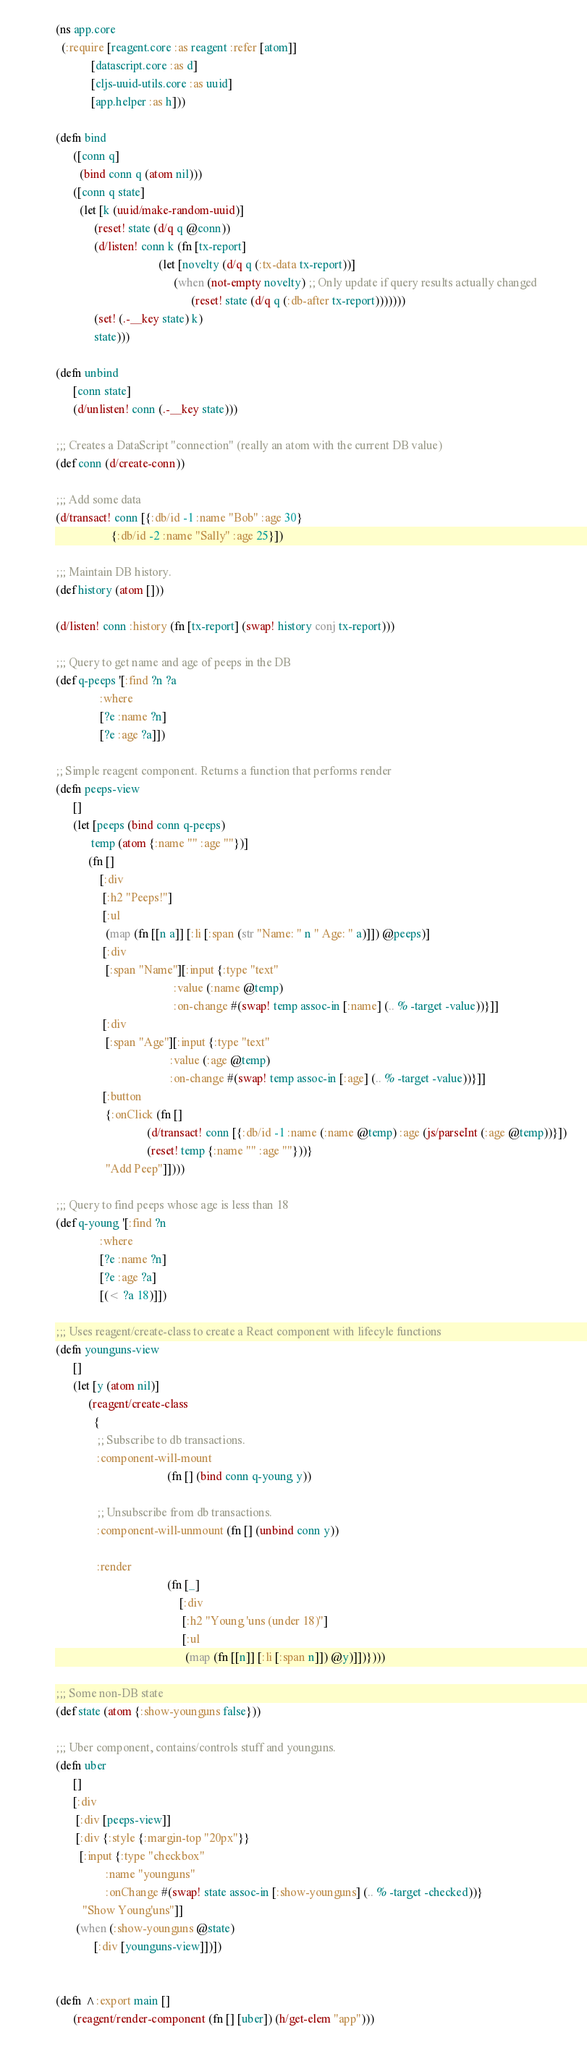<code> <loc_0><loc_0><loc_500><loc_500><_Clojure_>(ns app.core
  (:require [reagent.core :as reagent :refer [atom]]
            [datascript.core :as d]
            [cljs-uuid-utils.core :as uuid]
            [app.helper :as h]))

(defn bind
      ([conn q]
        (bind conn q (atom nil)))
      ([conn q state]
        (let [k (uuid/make-random-uuid)]
             (reset! state (d/q q @conn))
             (d/listen! conn k (fn [tx-report]
                                   (let [novelty (d/q q (:tx-data tx-report))]
                                        (when (not-empty novelty) ;; Only update if query results actually changed
                                              (reset! state (d/q q (:db-after tx-report)))))))
             (set! (.-__key state) k)
             state)))

(defn unbind
      [conn state]
      (d/unlisten! conn (.-__key state)))

;;; Creates a DataScript "connection" (really an atom with the current DB value)
(def conn (d/create-conn))

;;; Add some data
(d/transact! conn [{:db/id -1 :name "Bob" :age 30}
                   {:db/id -2 :name "Sally" :age 25}])

;;; Maintain DB history.
(def history (atom []))

(d/listen! conn :history (fn [tx-report] (swap! history conj tx-report)))

;;; Query to get name and age of peeps in the DB
(def q-peeps '[:find ?n ?a
               :where
               [?e :name ?n]
               [?e :age ?a]])

;; Simple reagent component. Returns a function that performs render
(defn peeps-view
      []
      (let [peeps (bind conn q-peeps)
            temp (atom {:name "" :age ""})]
           (fn []
               [:div
                [:h2 "Peeps!"]
                [:ul
                 (map (fn [[n a]] [:li [:span (str "Name: " n " Age: " a)]]) @peeps)]
                [:div
                 [:span "Name"][:input {:type "text"
                                        :value (:name @temp)
                                        :on-change #(swap! temp assoc-in [:name] (.. % -target -value))}]]
                [:div
                 [:span "Age"][:input {:type "text"
                                       :value (:age @temp)
                                       :on-change #(swap! temp assoc-in [:age] (.. % -target -value))}]]
                [:button
                 {:onClick (fn []
                               (d/transact! conn [{:db/id -1 :name (:name @temp) :age (js/parseInt (:age @temp))}])
                               (reset! temp {:name "" :age ""}))}
                 "Add Peep"]])))

;;; Query to find peeps whose age is less than 18
(def q-young '[:find ?n
               :where
               [?e :name ?n]
               [?e :age ?a]
               [(< ?a 18)]])

;;; Uses reagent/create-class to create a React component with lifecyle functions
(defn younguns-view
      []
      (let [y (atom nil)]
           (reagent/create-class
             {
              ;; Subscribe to db transactions.
              :component-will-mount
                                      (fn [] (bind conn q-young y))

              ;; Unsubscribe from db transactions.
              :component-will-unmount (fn [] (unbind conn y))

              :render
                                      (fn [_]
                                          [:div
                                           [:h2 "Young 'uns (under 18)"]
                                           [:ul
                                            (map (fn [[n]] [:li [:span n]]) @y)]])})))

;;; Some non-DB state
(def state (atom {:show-younguns false}))

;;; Uber component, contains/controls stuff and younguns.
(defn uber
      []
      [:div
       [:div [peeps-view]]
       [:div {:style {:margin-top "20px"}}
        [:input {:type "checkbox"
                 :name "younguns"
                 :onChange #(swap! state assoc-in [:show-younguns] (.. % -target -checked))}
         "Show Young'uns"]]
       (when (:show-younguns @state)
             [:div [younguns-view]])])


(defn ^:export main []
      (reagent/render-component (fn [] [uber]) (h/get-elem "app")))
</code> 